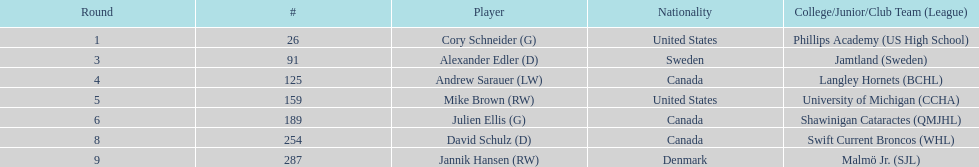Which player was the first player to be drafted? Cory Schneider (G). 